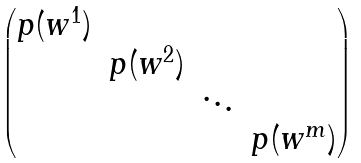Convert formula to latex. <formula><loc_0><loc_0><loc_500><loc_500>\begin{pmatrix} p ( w ^ { 1 } ) & & & \\ & p ( w ^ { 2 } ) & & \\ & & \ddots & \\ & & & p ( w ^ { m } ) \end{pmatrix}</formula> 